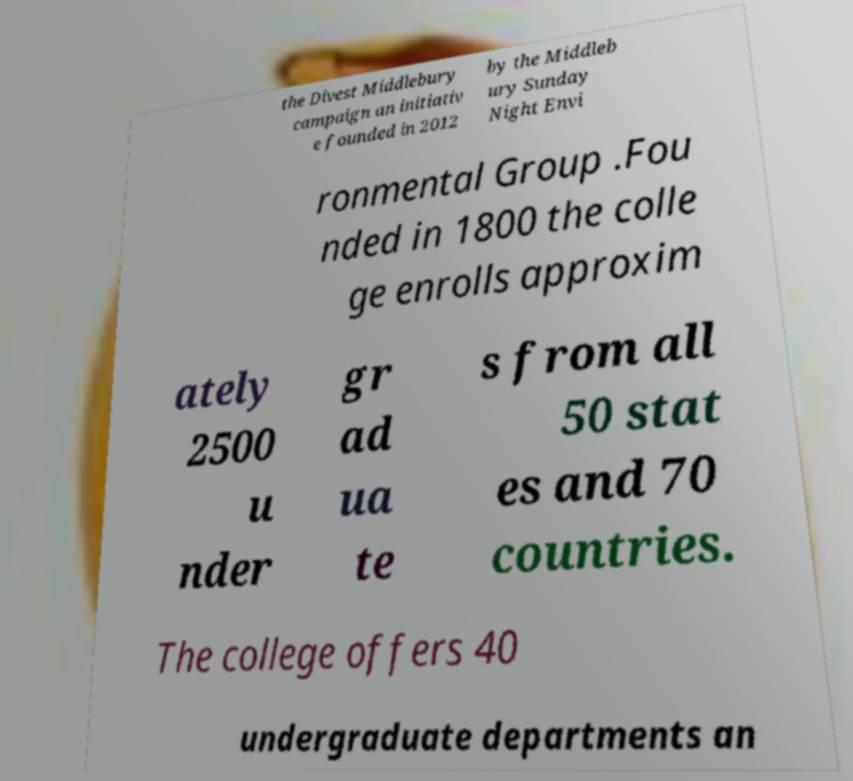Could you extract and type out the text from this image? the Divest Middlebury campaign an initiativ e founded in 2012 by the Middleb ury Sunday Night Envi ronmental Group .Fou nded in 1800 the colle ge enrolls approxim ately 2500 u nder gr ad ua te s from all 50 stat es and 70 countries. The college offers 40 undergraduate departments an 